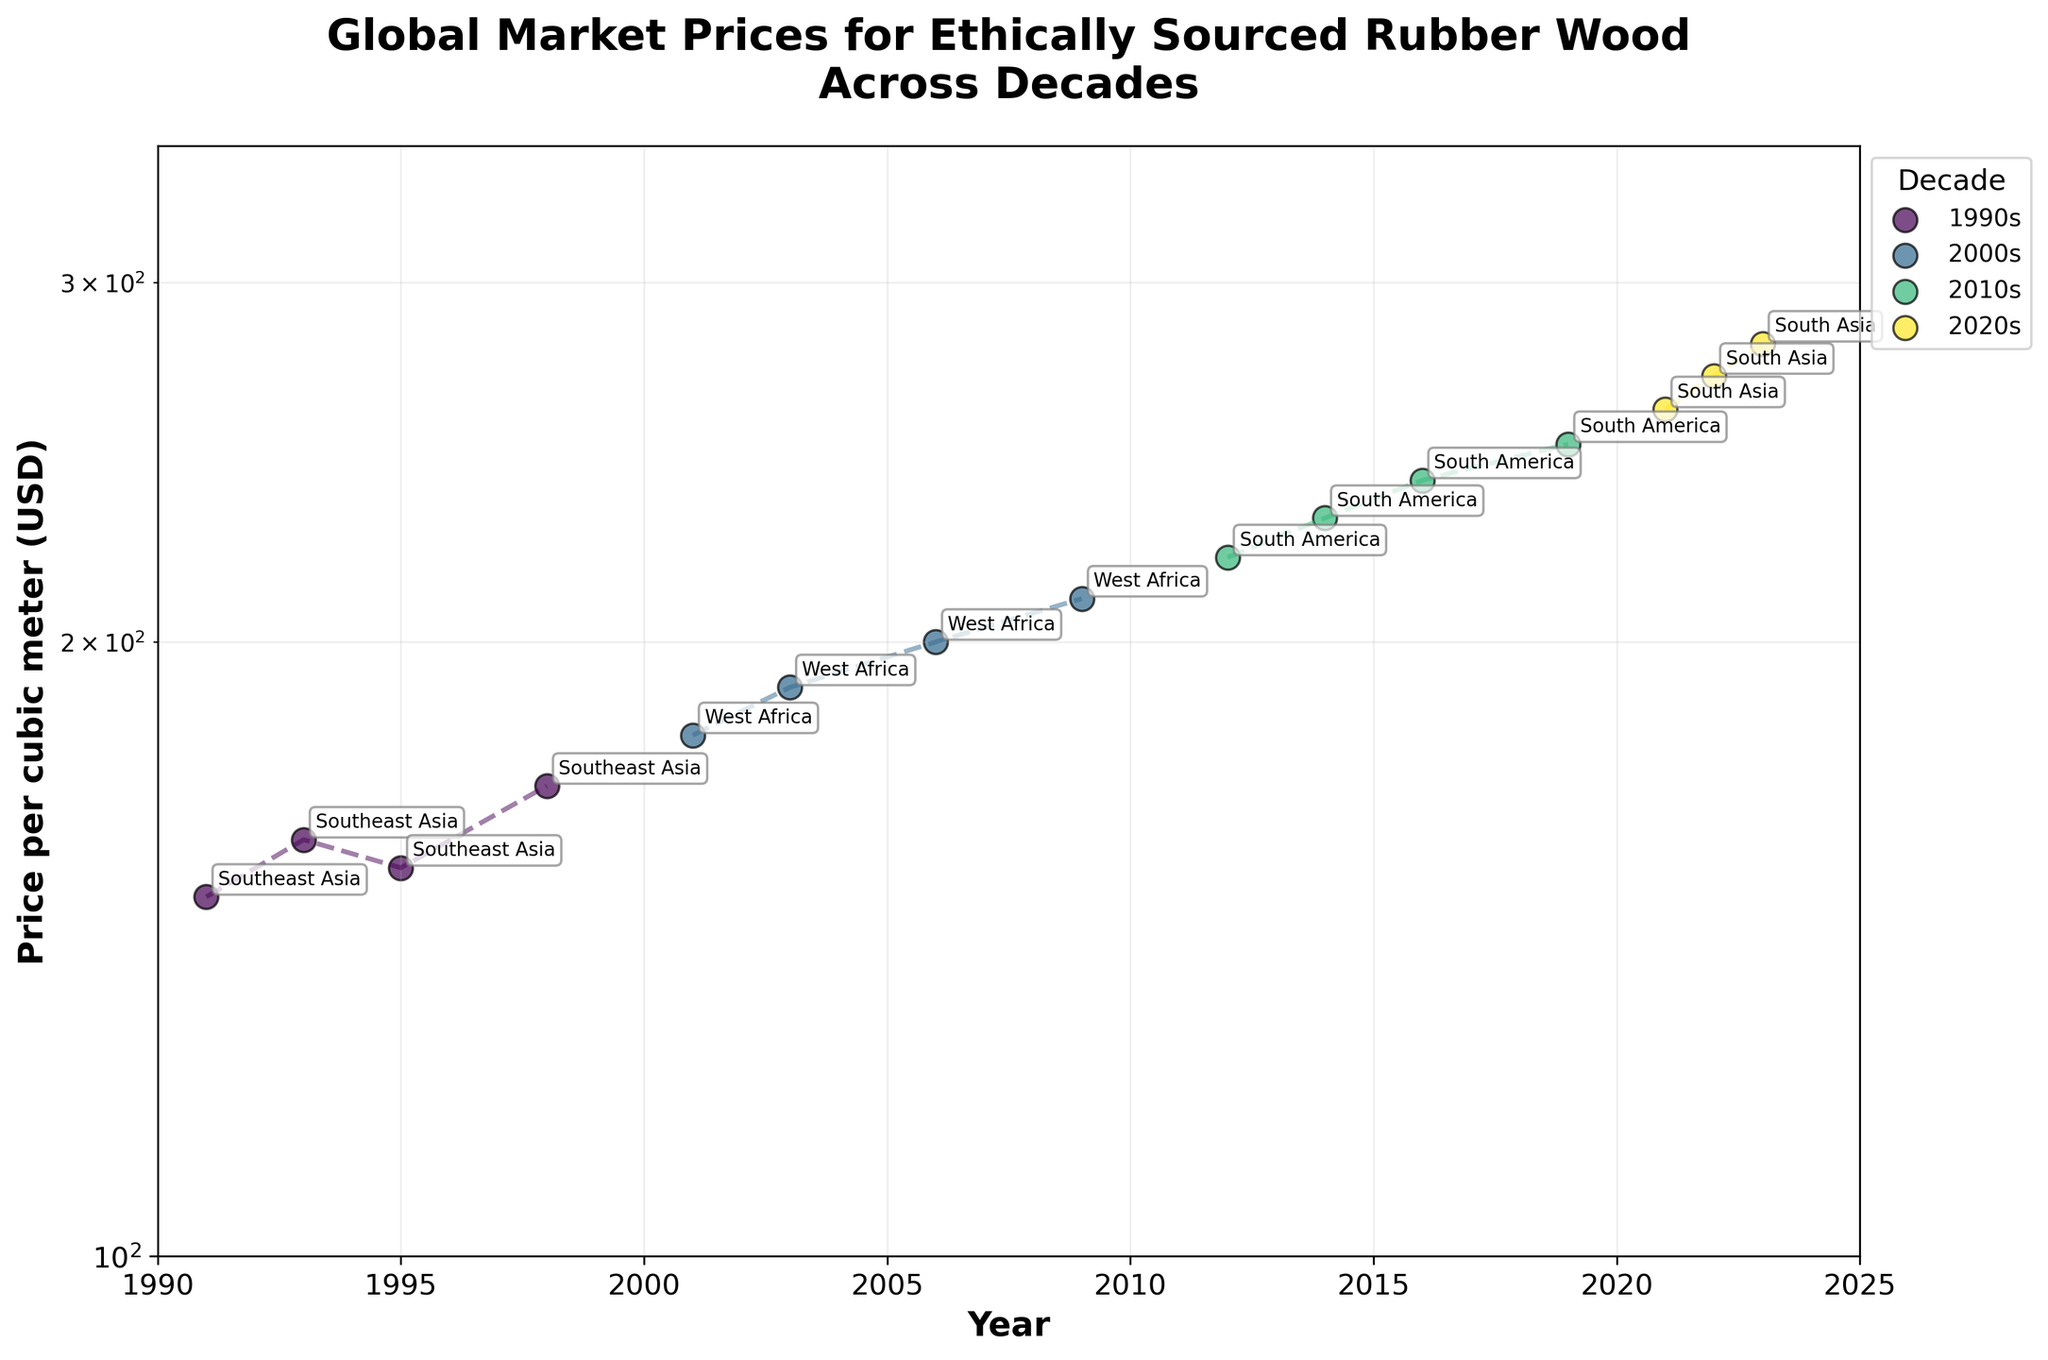How many decades are represented in the figure? There are four unique labels for the decades, each represented by a different color and label in the legend on the right side of the figure: 1990s, 2000s, 2010s, 2020s.
Answer: 4 What is the highest price per cubic meter in the 1990s? Looking at the scatterplot for the 1990s, the highest price is 170 USD in 1998.
Answer: 170 Which decade saw the highest increase in price over its duration? By observing the plotted lines for each decade, the steepest slope is in the 2020s, rising from 260 to 280 USD. This indicates a 20 USD increase. Other decades have smaller increases over their durations.
Answer: 2020s Which region is labeled at the highest price point in the figure? The highest price point is 280 USD, which is labeled as South Asia in 2023.
Answer: South Asia What is the trend in price for South America across the 2010s? The points for South America in the 2010s show a consistent upward trend from 220 USD in 2012 to 250 USD in 2019.
Answer: Upward trend Which region had the lowest initial price in the 2000s? In the 2000s, the initial price is 180 USD in 2001, and the region labeled at this point is West Africa.
Answer: West Africa Between Southeast Asia and West Africa, which region had a higher average price per cubic meter? Southeast Asia's prices are 150, 160, 155, 170, averaging (150+160+155+170)/4 = 158.75 USD. West Africa's prices are 180, 190, 200, 210, averaging (180+190+200+210)/4 = 195 USD. West Africa has the higher average.
Answer: West Africa In which year did the price for West Africa reach 200 USD? According to the plotted data, West Africa reached 200 USD in 2006.
Answer: 2006 How many data points are labeled for South America? The labeled points for South America in the 2010s are 2012, 2014, 2016, and 2019, making a total of four data points.
Answer: 4 What is the range of prices plotted on the y-axis? The y-axis is on a log scale and ranges from 100 to 350 USD.
Answer: 100 to 350 USD 